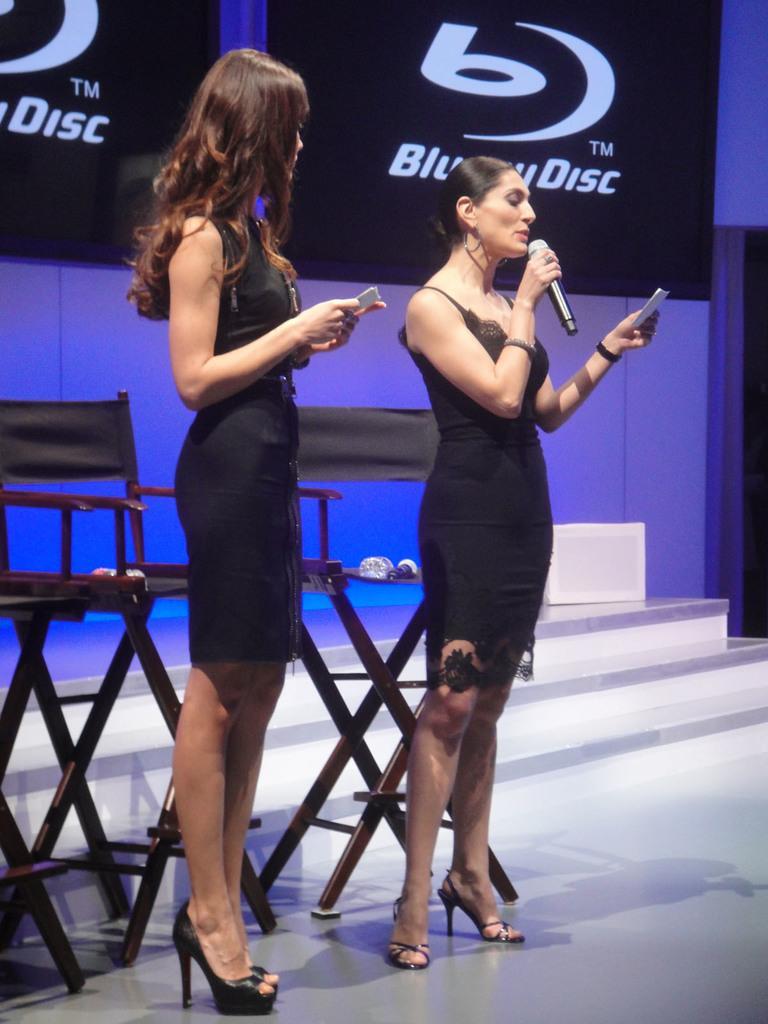Can you describe this image briefly? In this image, on the left, there is a lady standing and holding a paper in her hands and on the right, there is an another lady holding a mic and a paper. In the background, there is a board and we can see some chairs. 